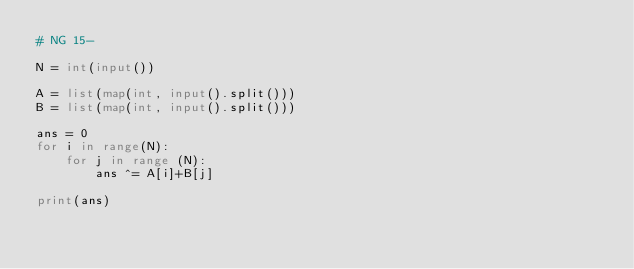<code> <loc_0><loc_0><loc_500><loc_500><_Python_># NG 15-

N = int(input())

A = list(map(int, input().split()))
B = list(map(int, input().split()))

ans = 0
for i in range(N):
    for j in range (N):
        ans ^= A[i]+B[j]

print(ans)
</code> 